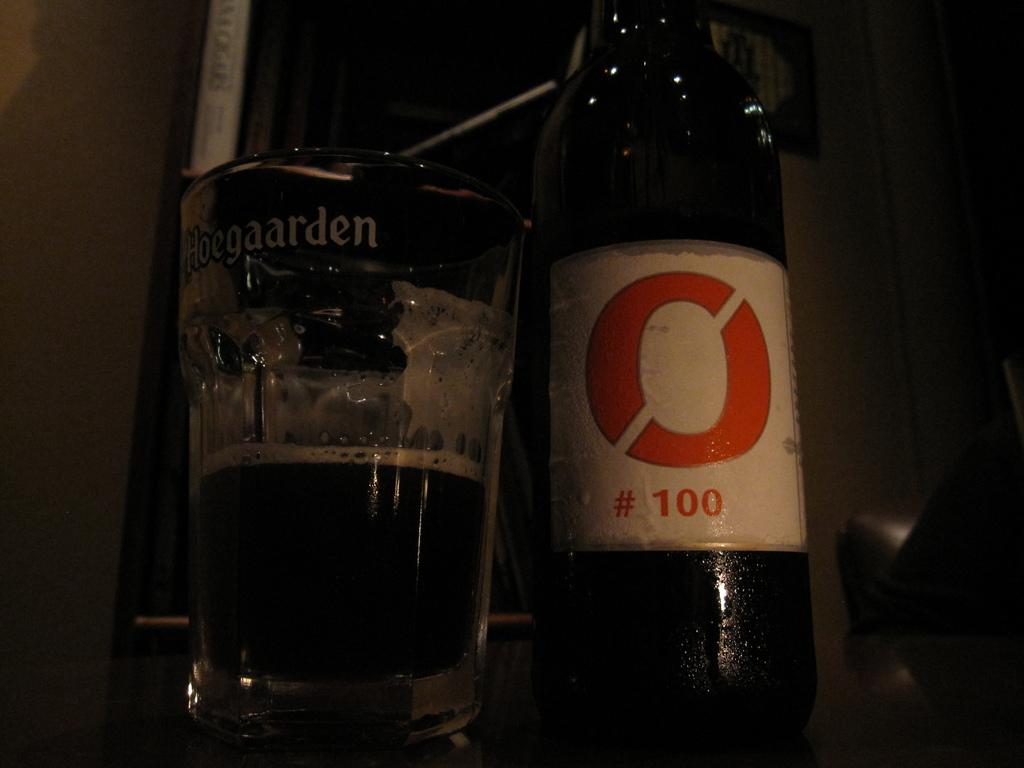What number is on the bottle?
Make the answer very short. 100. What is on the glass on the left?
Keep it short and to the point. Hoegaarden. 